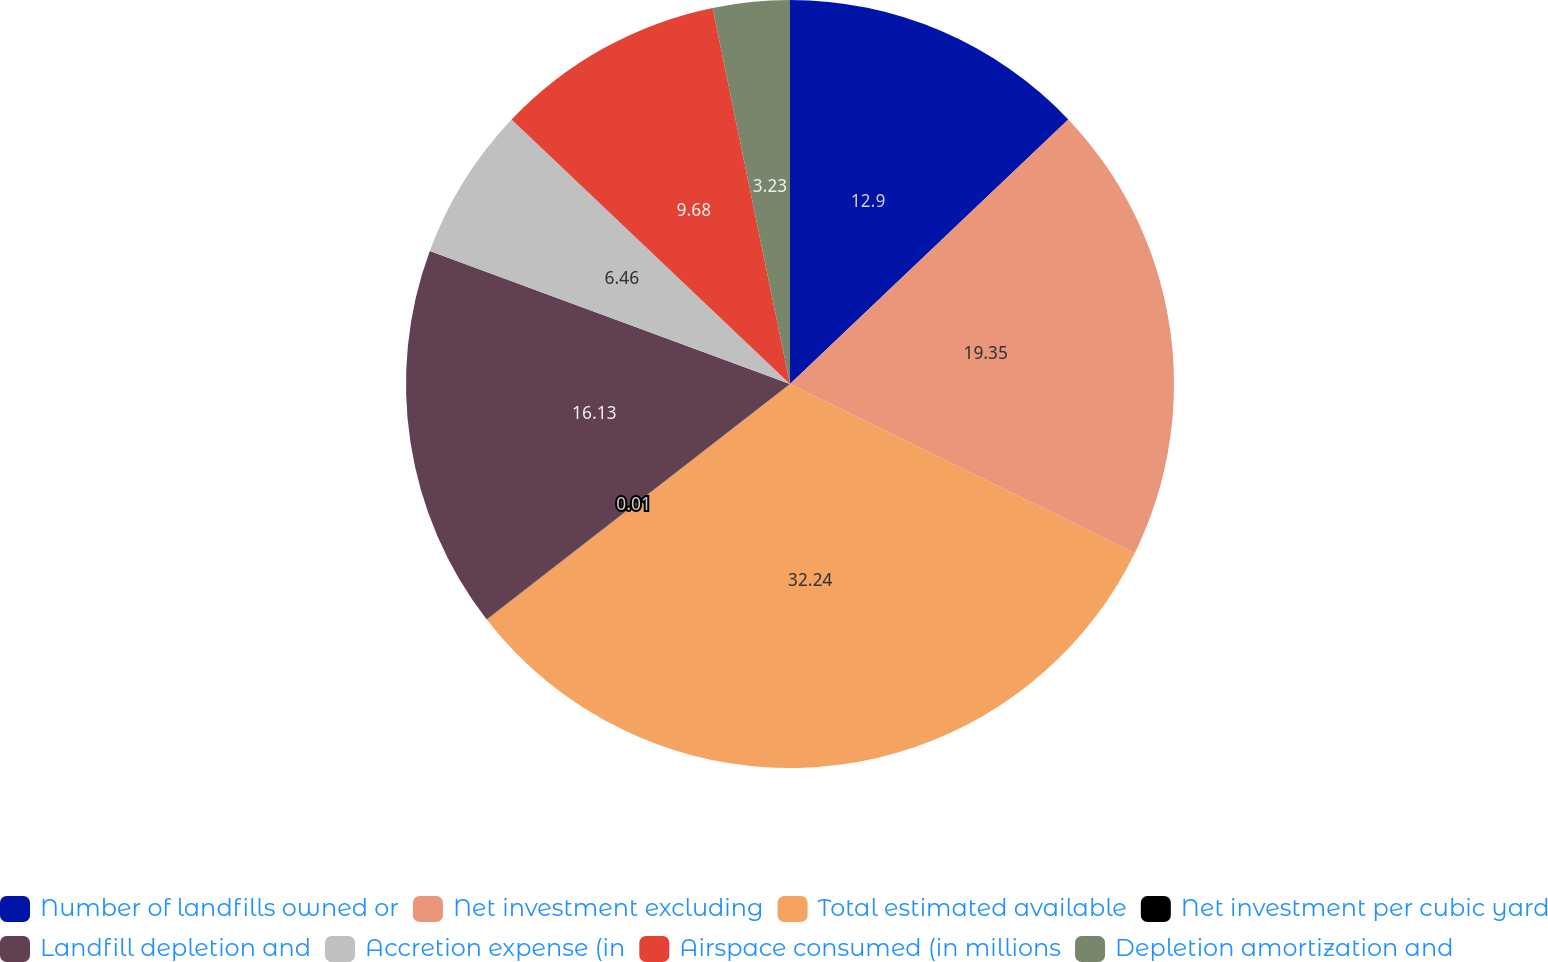<chart> <loc_0><loc_0><loc_500><loc_500><pie_chart><fcel>Number of landfills owned or<fcel>Net investment excluding<fcel>Total estimated available<fcel>Net investment per cubic yard<fcel>Landfill depletion and<fcel>Accretion expense (in<fcel>Airspace consumed (in millions<fcel>Depletion amortization and<nl><fcel>12.9%<fcel>19.35%<fcel>32.24%<fcel>0.01%<fcel>16.13%<fcel>6.46%<fcel>9.68%<fcel>3.23%<nl></chart> 